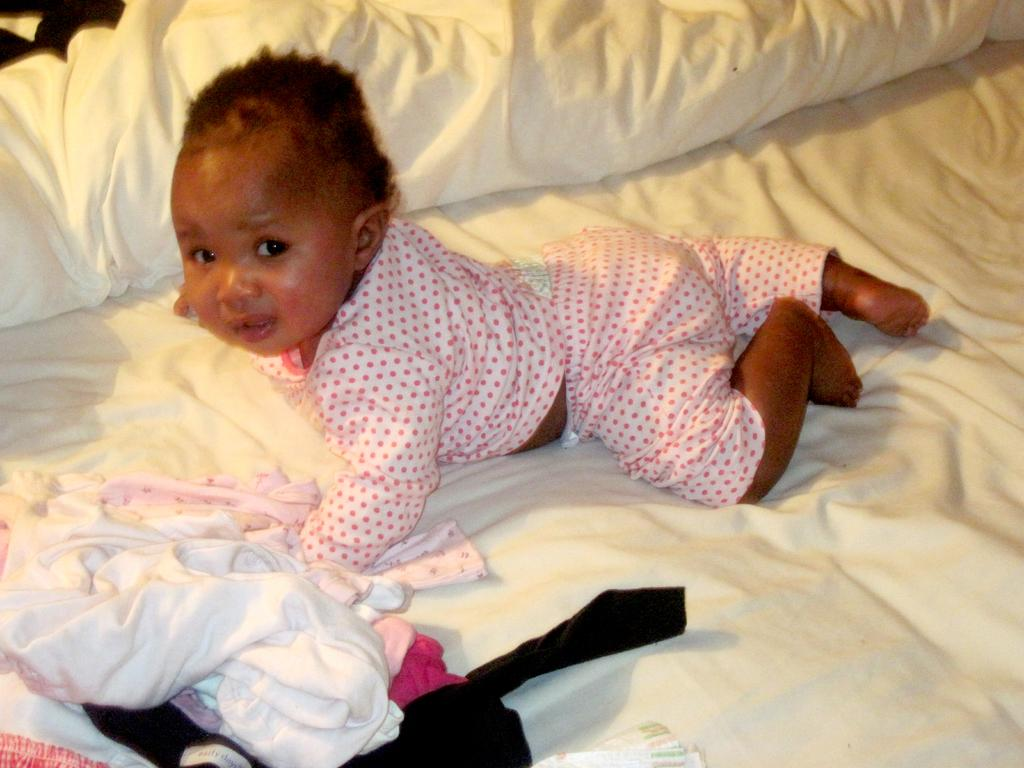What type of furniture is in the image? There is a couch in the image. What is on the couch? A baby is on the couch. Where can clothes be seen in the image? Clothes are visible at the left bottom of the image. Can you see any boats or harbors in the image? No, there are no boats or harbors present in the image. 